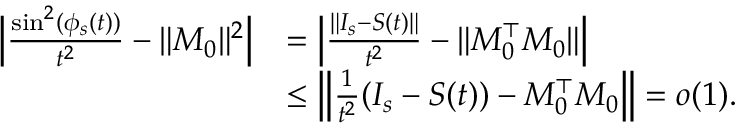<formula> <loc_0><loc_0><loc_500><loc_500>\begin{array} { r l } { \left | \frac { \sin ^ { 2 } ( \phi _ { s } ( t ) ) } { t ^ { 2 } } - \| M _ { 0 } \| ^ { 2 } \right | } & { = \left | \frac { \| I _ { s } - S ( t ) \| } { t ^ { 2 } } - \| M _ { 0 } ^ { \top } M _ { 0 } \| \right | } \\ & { \leq \left \| \frac { 1 } { t ^ { 2 } } ( I _ { s } - S ( t ) ) - M _ { 0 } ^ { \top } M _ { 0 } \right \| = o ( 1 ) . } \end{array}</formula> 